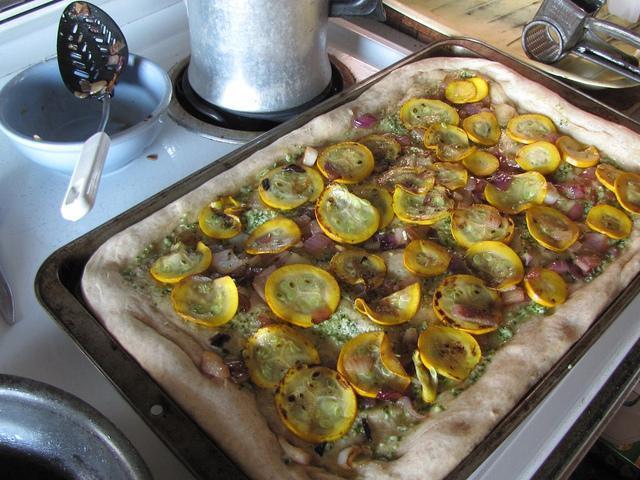How many bowls are in the photo?
Give a very brief answer. 1. How many women are shown?
Give a very brief answer. 0. 